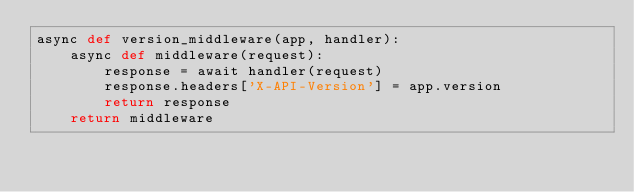Convert code to text. <code><loc_0><loc_0><loc_500><loc_500><_Python_>async def version_middleware(app, handler):
    async def middleware(request):
        response = await handler(request)
        response.headers['X-API-Version'] = app.version
        return response
    return middleware
</code> 